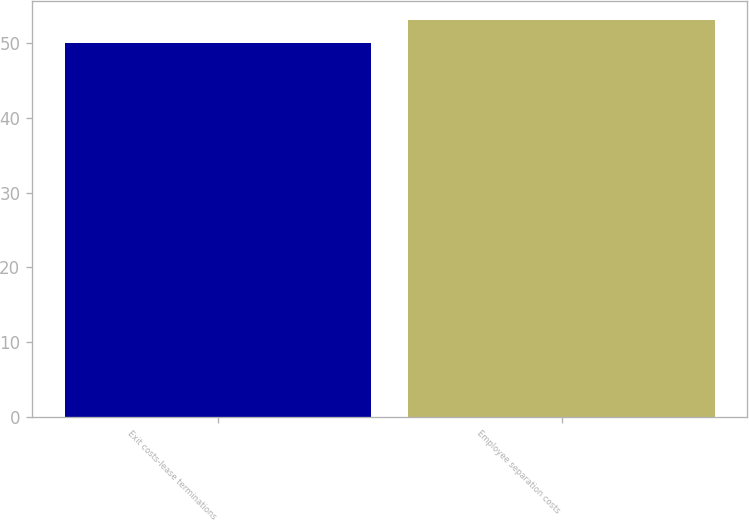Convert chart. <chart><loc_0><loc_0><loc_500><loc_500><bar_chart><fcel>Exit costs-lease terminations<fcel>Employee separation costs<nl><fcel>50<fcel>53<nl></chart> 